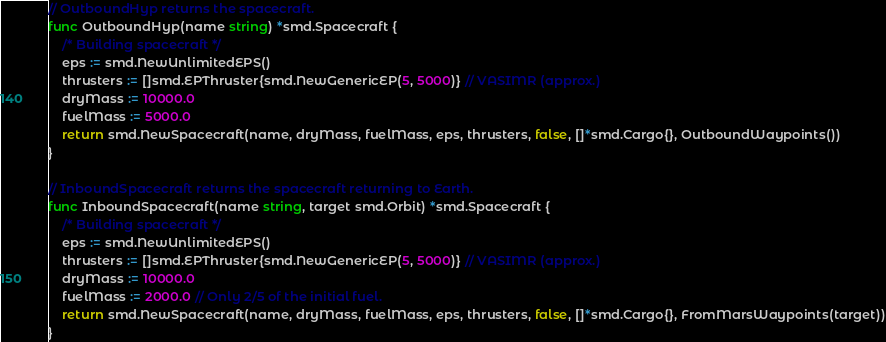<code> <loc_0><loc_0><loc_500><loc_500><_Go_>// OutboundHyp returns the spacecraft.
func OutboundHyp(name string) *smd.Spacecraft {
	/* Building spacecraft */
	eps := smd.NewUnlimitedEPS()
	thrusters := []smd.EPThruster{smd.NewGenericEP(5, 5000)} // VASIMR (approx.)
	dryMass := 10000.0
	fuelMass := 5000.0
	return smd.NewSpacecraft(name, dryMass, fuelMass, eps, thrusters, false, []*smd.Cargo{}, OutboundWaypoints())
}

// InboundSpacecraft returns the spacecraft returning to Earth.
func InboundSpacecraft(name string, target smd.Orbit) *smd.Spacecraft {
	/* Building spacecraft */
	eps := smd.NewUnlimitedEPS()
	thrusters := []smd.EPThruster{smd.NewGenericEP(5, 5000)} // VASIMR (approx.)
	dryMass := 10000.0
	fuelMass := 2000.0 // Only 2/5 of the initial fuel.
	return smd.NewSpacecraft(name, dryMass, fuelMass, eps, thrusters, false, []*smd.Cargo{}, FromMarsWaypoints(target))
}
</code> 